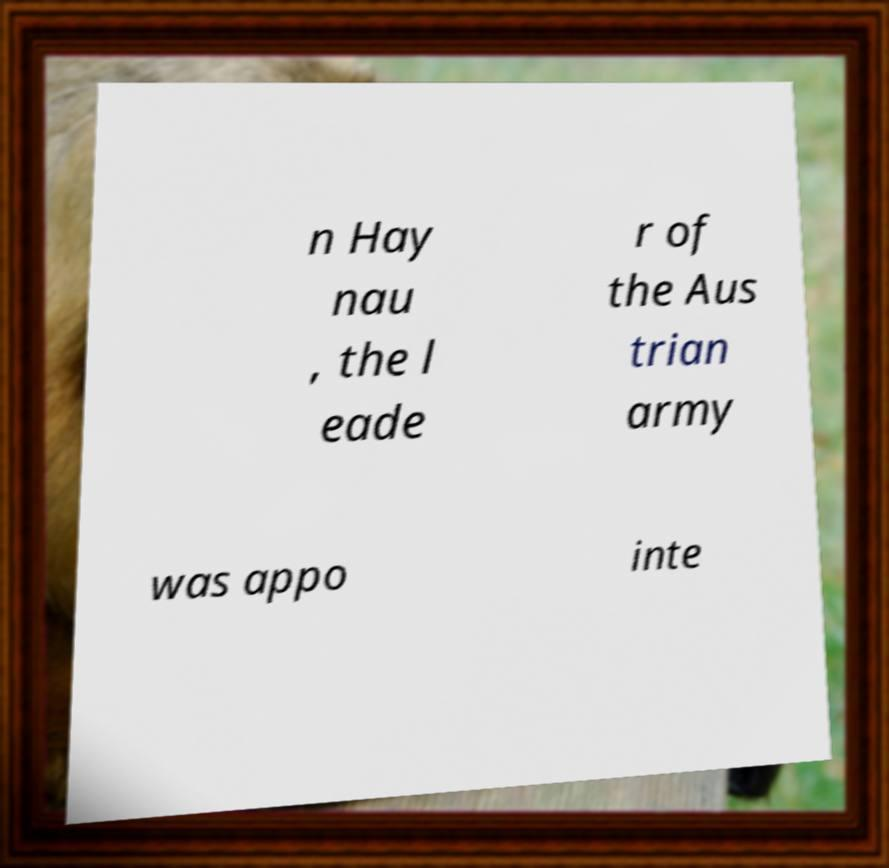What messages or text are displayed in this image? I need them in a readable, typed format. n Hay nau , the l eade r of the Aus trian army was appo inte 